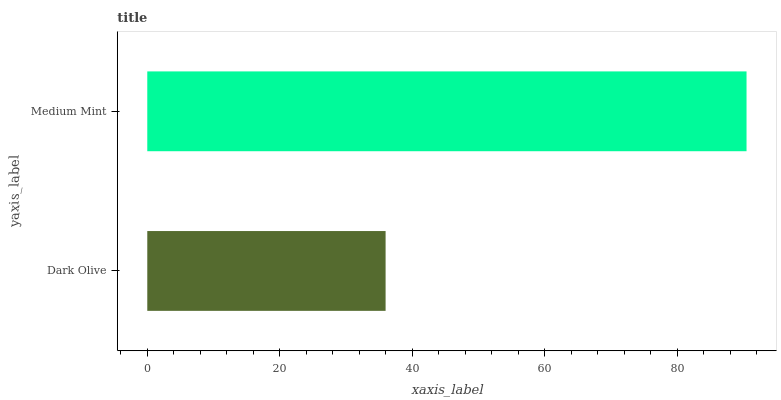Is Dark Olive the minimum?
Answer yes or no. Yes. Is Medium Mint the maximum?
Answer yes or no. Yes. Is Medium Mint the minimum?
Answer yes or no. No. Is Medium Mint greater than Dark Olive?
Answer yes or no. Yes. Is Dark Olive less than Medium Mint?
Answer yes or no. Yes. Is Dark Olive greater than Medium Mint?
Answer yes or no. No. Is Medium Mint less than Dark Olive?
Answer yes or no. No. Is Medium Mint the high median?
Answer yes or no. Yes. Is Dark Olive the low median?
Answer yes or no. Yes. Is Dark Olive the high median?
Answer yes or no. No. Is Medium Mint the low median?
Answer yes or no. No. 